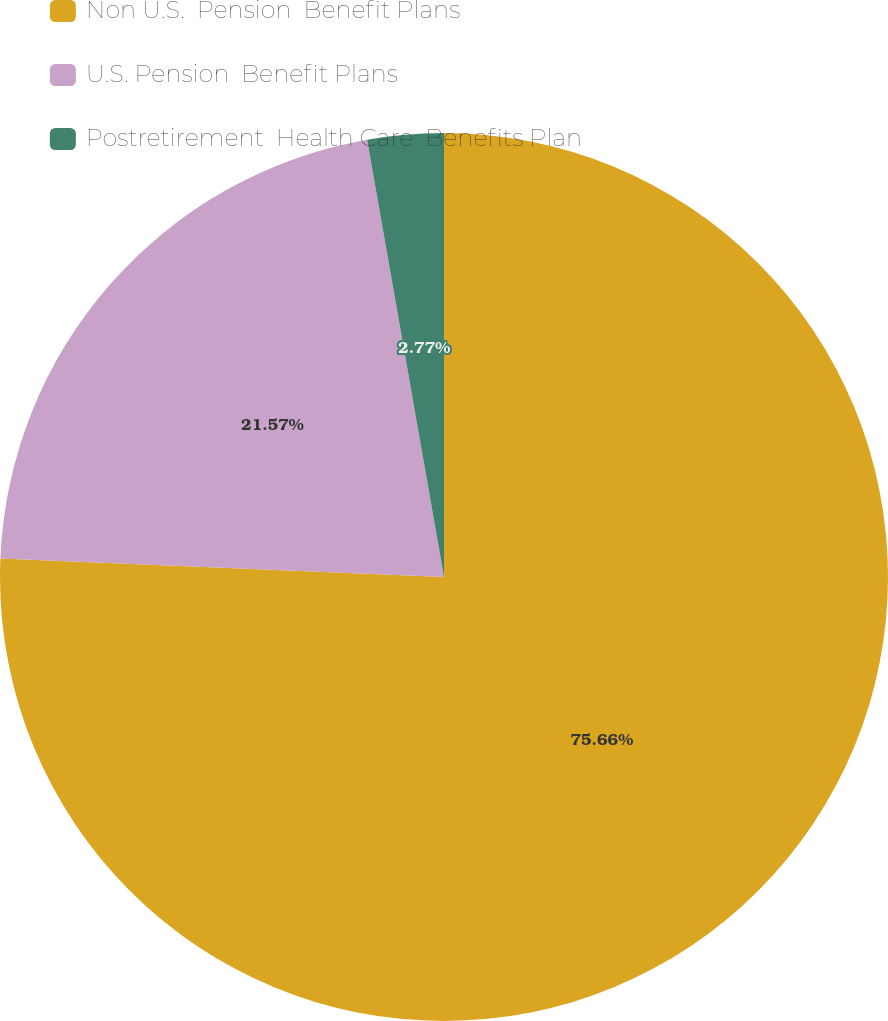<chart> <loc_0><loc_0><loc_500><loc_500><pie_chart><fcel>Non U.S.  Pension  Benefit Plans<fcel>U.S. Pension  Benefit Plans<fcel>Postretirement  Health Care  Benefits Plan<nl><fcel>75.66%<fcel>21.57%<fcel>2.77%<nl></chart> 